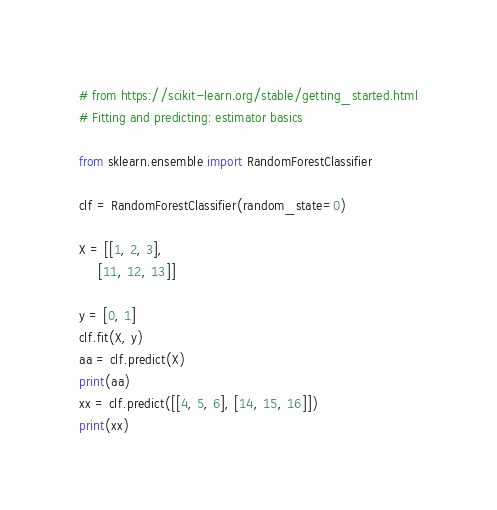Convert code to text. <code><loc_0><loc_0><loc_500><loc_500><_Python_># from https://scikit-learn.org/stable/getting_started.html
# Fitting and predicting: estimator basics

from sklearn.ensemble import RandomForestClassifier

clf = RandomForestClassifier(random_state=0)

X = [[1, 2, 3],
     [11, 12, 13]]

y = [0, 1]
clf.fit(X, y)
aa = clf.predict(X)
print(aa)
xx = clf.predict([[4, 5, 6], [14, 15, 16]])
print(xx)</code> 